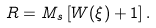Convert formula to latex. <formula><loc_0><loc_0><loc_500><loc_500>R = M _ { s } \left [ W ( \xi ) + 1 \right ] .</formula> 